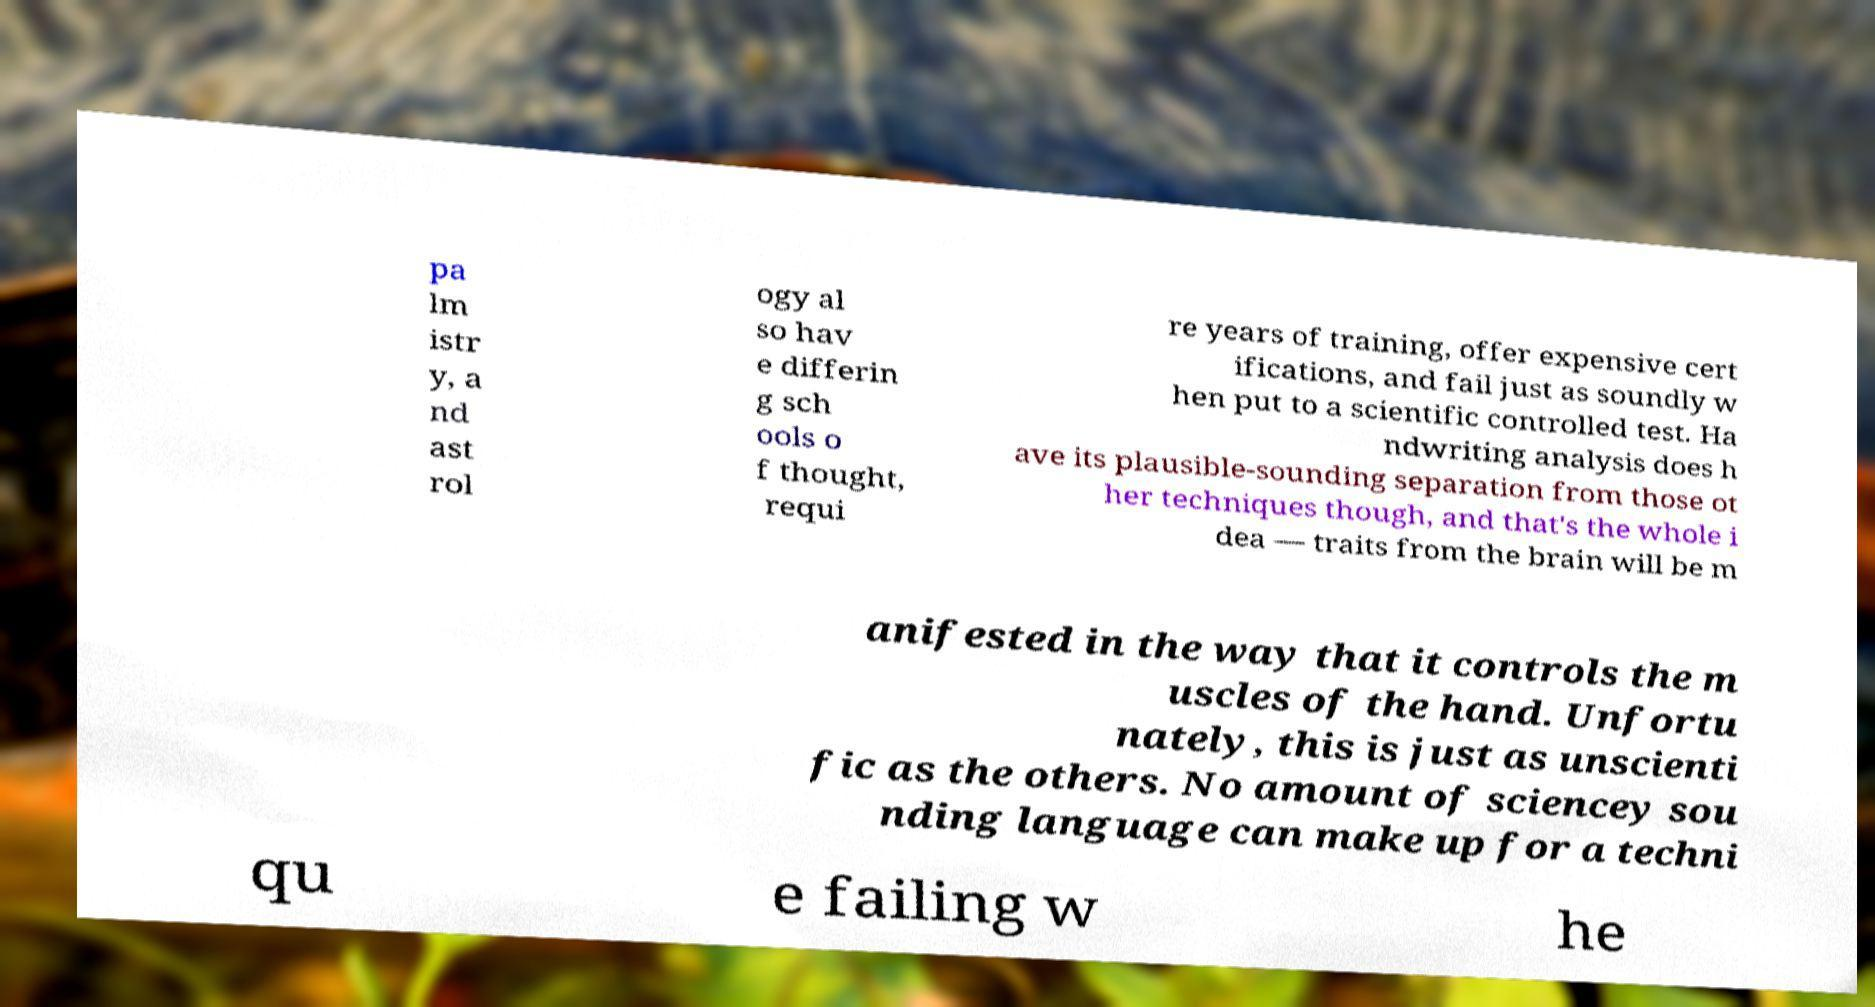There's text embedded in this image that I need extracted. Can you transcribe it verbatim? pa lm istr y, a nd ast rol ogy al so hav e differin g sch ools o f thought, requi re years of training, offer expensive cert ifications, and fail just as soundly w hen put to a scientific controlled test. Ha ndwriting analysis does h ave its plausible-sounding separation from those ot her techniques though, and that's the whole i dea — traits from the brain will be m anifested in the way that it controls the m uscles of the hand. Unfortu nately, this is just as unscienti fic as the others. No amount of sciencey sou nding language can make up for a techni qu e failing w he 